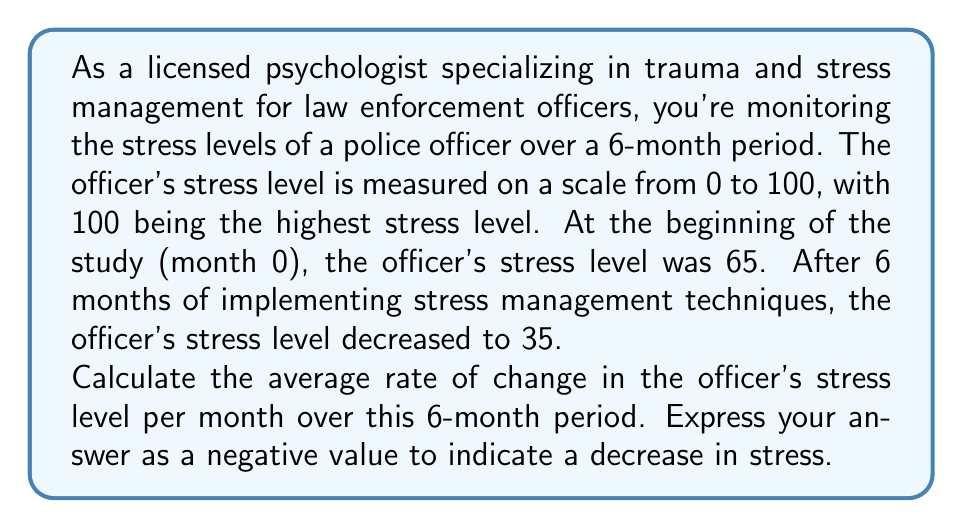Could you help me with this problem? To solve this problem, we'll use the formula for the average rate of change:

$$\text{Average rate of change} = \frac{\text{Change in y}}{\text{Change in x}}$$

Where:
- y represents the stress level
- x represents the time in months

Let's identify our values:
- Initial stress level (y₁) = 65
- Final stress level (y₂) = 35
- Initial time (x₁) = 0 months
- Final time (x₂) = 6 months

Now, let's calculate:

1) Change in y (stress level):
   $$\Delta y = y₂ - y₁ = 35 - 65 = -30$$

2) Change in x (time):
   $$\Delta x = x₂ - x₁ = 6 - 0 = 6 \text{ months}$$

3) Apply the formula:
   $$\text{Average rate of change} = \frac{\Delta y}{\Delta x} = \frac{-30}{6} = -5$$

The negative value indicates a decrease in stress level over time.
Answer: The average rate of change in the officer's stress level is $-5$ units per month. 